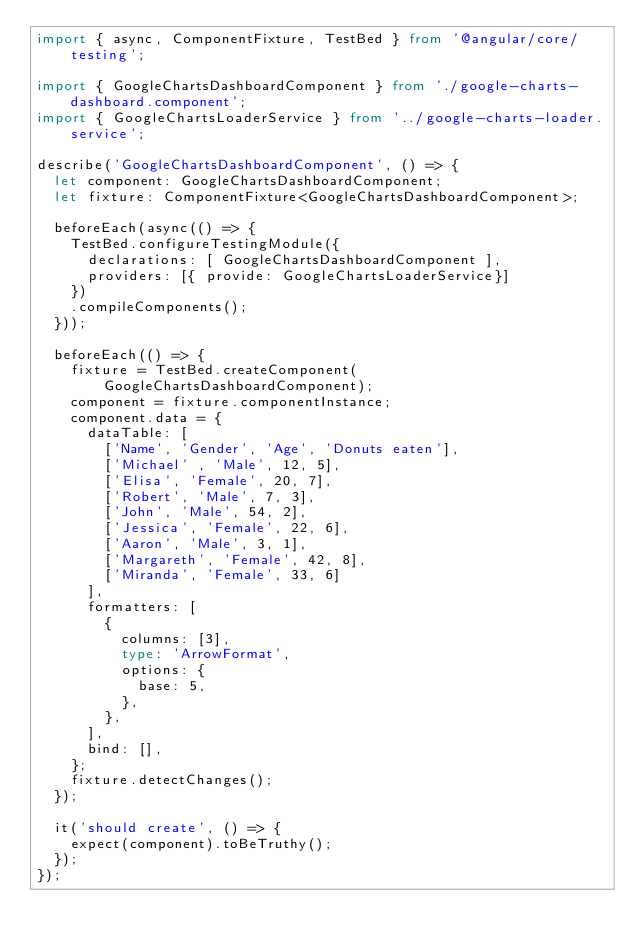Convert code to text. <code><loc_0><loc_0><loc_500><loc_500><_TypeScript_>import { async, ComponentFixture, TestBed } from '@angular/core/testing';

import { GoogleChartsDashboardComponent } from './google-charts-dashboard.component';
import { GoogleChartsLoaderService } from '../google-charts-loader.service';

describe('GoogleChartsDashboardComponent', () => {
  let component: GoogleChartsDashboardComponent;
  let fixture: ComponentFixture<GoogleChartsDashboardComponent>;

  beforeEach(async(() => {
    TestBed.configureTestingModule({
      declarations: [ GoogleChartsDashboardComponent ],
      providers: [{ provide: GoogleChartsLoaderService}]
    })
    .compileComponents();
  }));

  beforeEach(() => {
    fixture = TestBed.createComponent(GoogleChartsDashboardComponent);
    component = fixture.componentInstance;
    component.data = {
      dataTable: [
        ['Name', 'Gender', 'Age', 'Donuts eaten'],
        ['Michael' , 'Male', 12, 5],
        ['Elisa', 'Female', 20, 7],
        ['Robert', 'Male', 7, 3],
        ['John', 'Male', 54, 2],
        ['Jessica', 'Female', 22, 6],
        ['Aaron', 'Male', 3, 1],
        ['Margareth', 'Female', 42, 8],
        ['Miranda', 'Female', 33, 6]
      ],
      formatters: [
        {
          columns: [3],
          type: 'ArrowFormat',
          options: {
            base: 5,
          },
        },
      ],
      bind: [],
    };
    fixture.detectChanges();
  });

  it('should create', () => {
    expect(component).toBeTruthy();
  });
});
</code> 